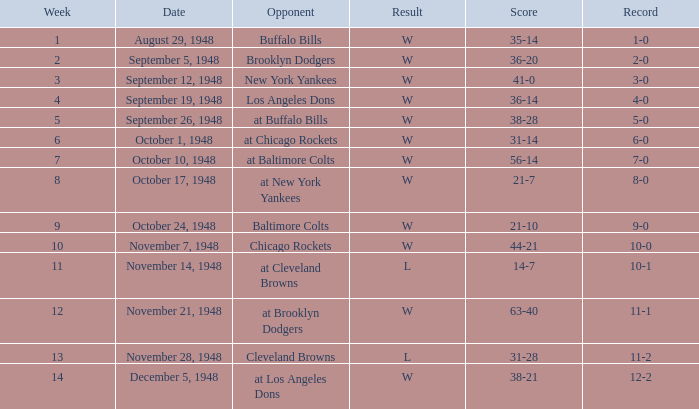Who was the opponent in week 13? Cleveland Browns. 